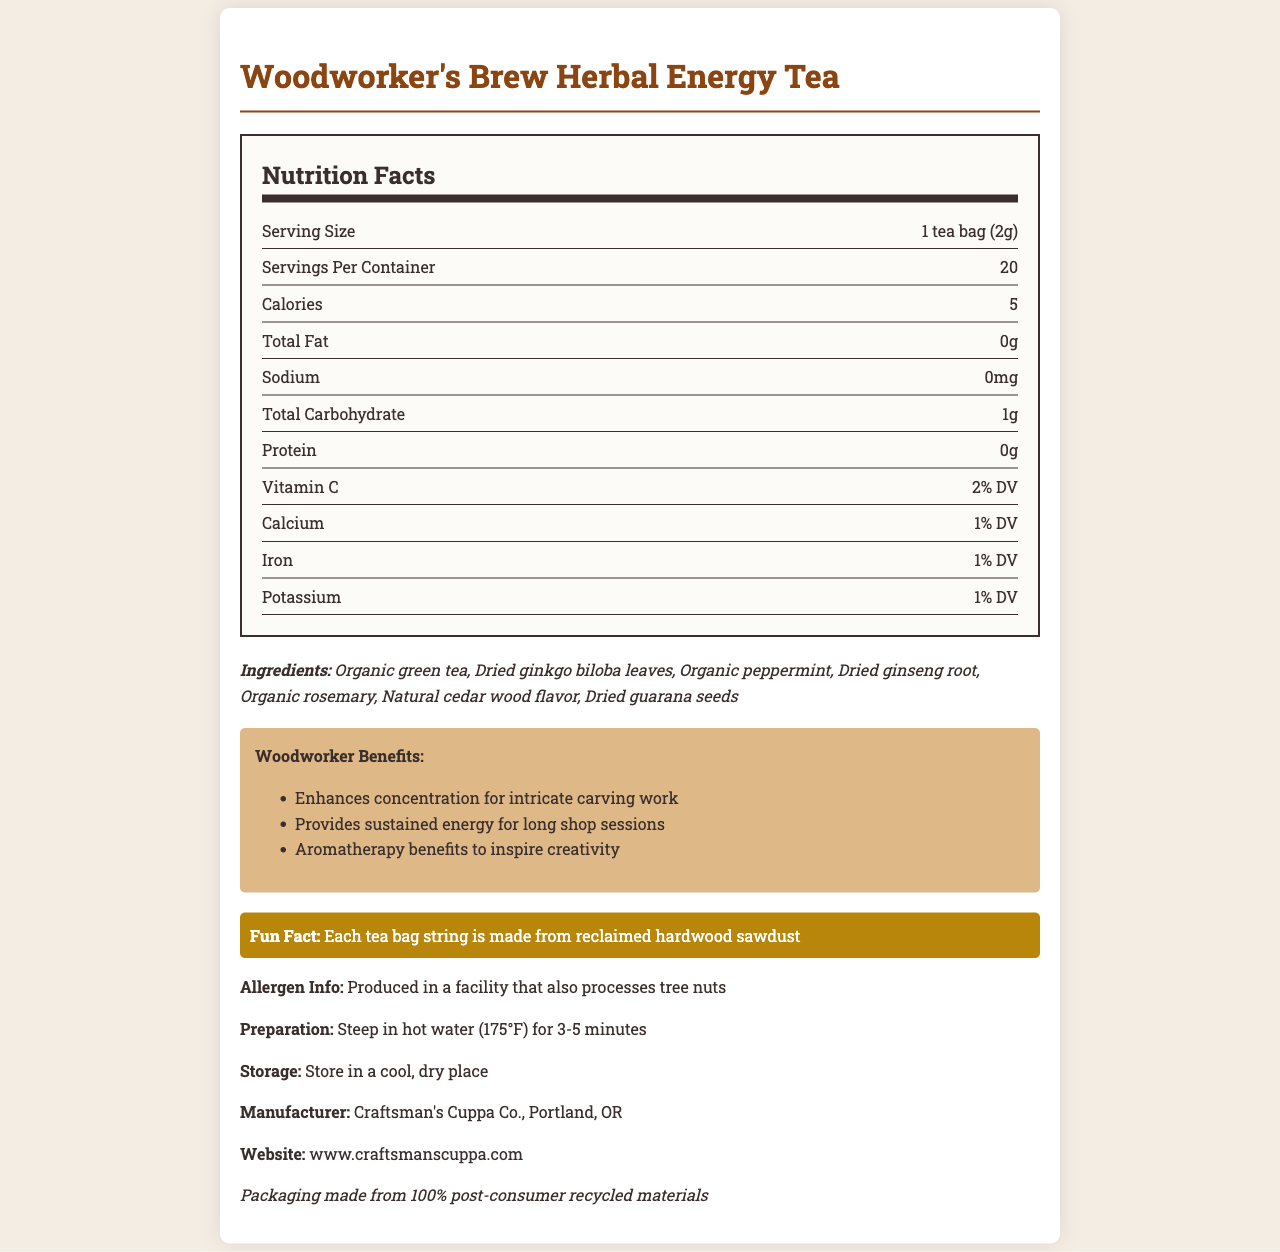what is the serving size? The serving size is specified as "1 tea bag (2g)" in the nutrition label section.
Answer: 1 tea bag (2g) how many servings are in a container? The document states that there are 20 servings per container.
Answer: 20 what is the calorie count per serving? The nutrition label mentions that each serving contains 5 calories.
Answer: 5 what is the total carbohydrate content per serving? According to the nutrition label, the total carbohydrate content per serving is 1 gram.
Answer: 1g what are the specific benefits for woodworkers mentioned? The document lists "Enhances concentration for intricate carving work," "Provides sustained energy for long shop sessions," and "Aromatherapy benefits to inspire creativity" as the benefits for woodworkers.
Answer: Enhances concentration for intricate carving work, Provides sustained energy for long shop sessions, Aromatherapy benefits to inspire creativity which ingredient in the tea blend is organic? A. Ginkgo biloba B. Peppermint C. Rosemary D. Guarana seeds The ingredients list shows that Organic rosemary is marked as organic, while the others are not specified as organic.
Answer: C. Rosemary what percentage of daily value (DV) does the tea provide for Vitamin C? A. 1% B. 2% C. 10% D. 100% The nutrition label states that the tea provides 2% of the daily value (DV) for Vitamin C.
Answer: B. 2% does the tea contain any protein? The nutrition label indicates that the tea contains 0g of protein.
Answer: No is the tea suitable for someone with a tree nut allergy? The allergen information states that the tea is produced in a facility that also processes tree nuts, indicating potential cross-contamination risks for those with tree nut allergies.
Answer: No describe the main idea of the document. The document provides comprehensive details about the herbal energy tea, focusing on its nutritional value, specific woodworker benefits, ingredients, and additional notes on preparation, storage, and sustainability.
Answer: The document presents a nutrition facts label for "Woodworker's Brew Herbal Energy Tea," highlighting its nutritional content, the ingredients used, specific benefits for woodworkers, preparation instructions, storage recommendations, and sustainability notes. It is specially marketed towards woodworkers, emphasizing benefits like enhanced concentration, sustained energy, and aromatherapy to inspire creativity. does the tea include any caffeine-containing ingredients? The ingredients list includes Organic green tea and Dried guarana seeds, both of which are known to contain caffeine.
Answer: Yes what is the manufacturer's location? The document specifies that the manufacturer, Craftsman's Cuppa Co., is located in Portland, OR.
Answer: Portland, OR how should the tea be stored? The storage instructions state that the tea should be stored in a cool, dry place.
Answer: Store in a cool, dry place what is the fun fact about the tea bags? The fun fact section notes that each tea bag string is made from reclaimed hardwood sawdust.
Answer: Each tea bag string is made from reclaimed hardwood sawdust can the document tell how much caffeine is in each serving? The document lists ingredients known to contain caffeine but does not provide specific caffeine content per serving.
Answer: Not enough information 